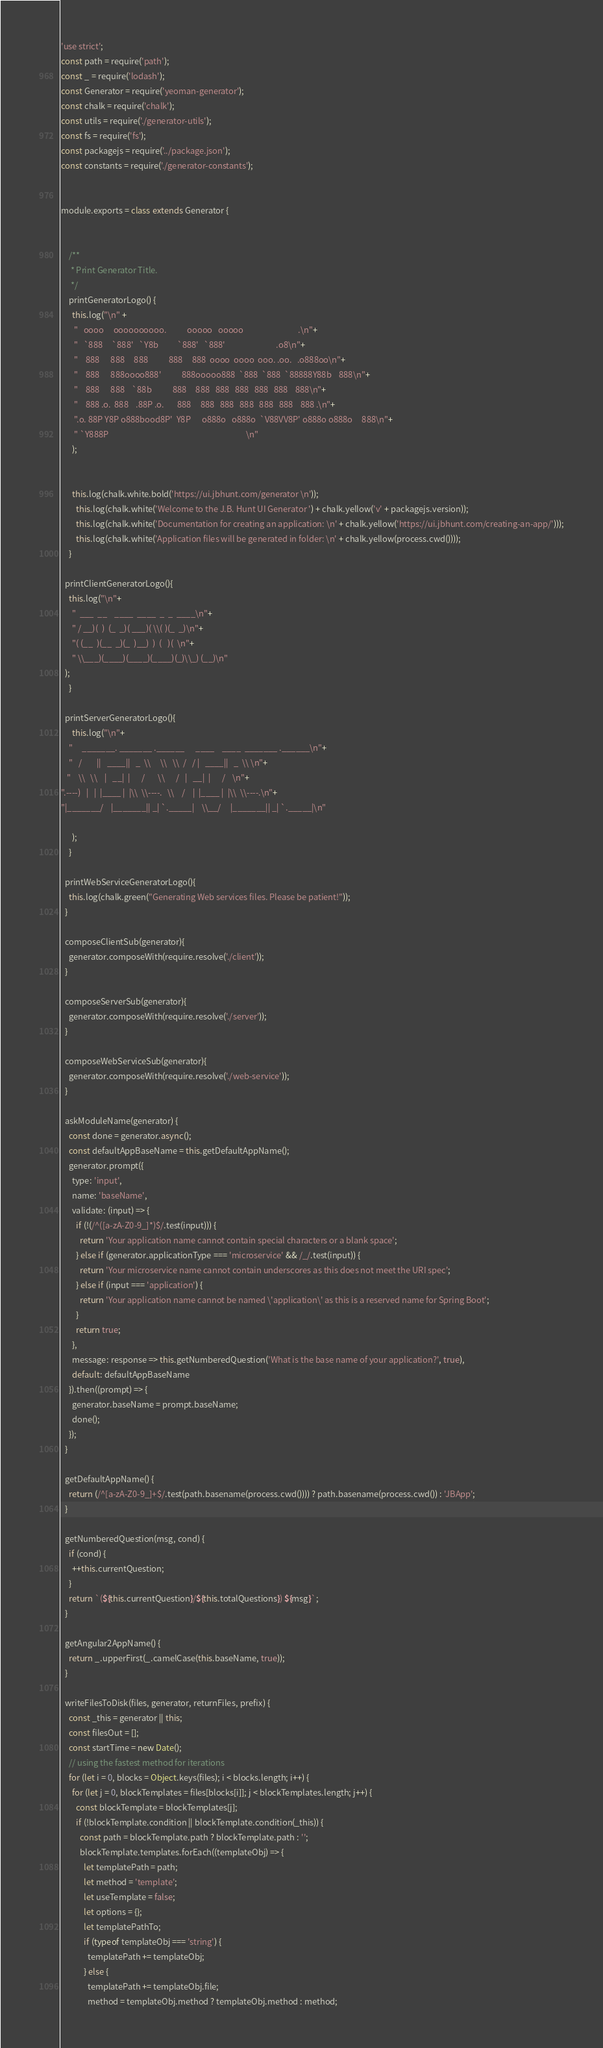<code> <loc_0><loc_0><loc_500><loc_500><_JavaScript_>'use strict';
const path = require('path');
const _ = require('lodash');
const Generator = require('yeoman-generator');
const chalk = require('chalk');
const utils = require('./generator-utils');
const fs = require('fs');
const packagejs = require('../package.json');
const constants = require('./generator-constants');


module.exports = class extends Generator {


    /**
     * Print Generator Title.
     */
    printGeneratorLogo() {
      this.log("\n" +
       "   oooo     oooooooooo.           ooooo   ooooo                             .\n"+
       "   `888     `888'   `Y8b          `888'   `888'                           .o8\n"+
       "    888      888     888           888     888  oooo  oooo  ooo. .oo.   .o888oo\n"+
       "    888      888oooo888'           888ooooo888  `888  `888  `88888Y88b    888\n"+
       "    888      888    `88b           888     888   888   888   888   888    888\n"+
       "    888 .o.  888    .88P .o.       888     888   888   888   888   888    888 .\n"+
       ".o. 88P Y8P o888bood8P'  Y8P      o888o   o888o  `V88VV8P' o888o o888o     888\n"+
       " `Y888P                                                                         \n"
      );


      this.log(chalk.white.bold('https://ui.jbhunt.com/generator \n'));
        this.log(chalk.white('Welcome to the J.B. Hunt UI Generator ') + chalk.yellow('v' + packagejs.version));
        this.log(chalk.white('Documentation for creating an application: \n' + chalk.yellow('https://ui.jbhunt.com/creating-an-app/')));
        this.log(chalk.white('Application files will be generated in folder: \n' + chalk.yellow(process.cwd())));
    }

  printClientGeneratorLogo(){
    this.log("\n"+
      "  ___  __    ____  ____  _  _  ____\n"+
      " / __)(  )  (_  _)( ___)( \\( )(_  _)\n"+
      "( (__  )(__  _)(_  )__)  )  (   )(  \n"+
      " \\___)(____)(____)(____)(_)\\_) (__)\n"
  );
    }

  printServerGeneratorLogo(){
      this.log("\n"+
    "     _______. _______ .______      ____    ____  _______ .______\n"+
    "   /        ||   ____||   _  \\     \\   \\  /   / |   ____||   _  \\ \n"+
   "    \\   \\    |   __|  |      /       \\      /   |   __|  |      /    \n"+
".----)   |   |  |____ |  |\\  \\----.   \\    /    |  |____ |  |\\  \\----.\n"+
"|_______/    |_______|| _| `._____|    \\__/     |_______|| _| `._____|\n"

      );
    }

  printWebServiceGeneratorLogo(){
    this.log(chalk.green("Generating Web services files. Please be patient!"));
  }

  composeClientSub(generator){
    generator.composeWith(require.resolve('./client'));
  }

  composeServerSub(generator){
    generator.composeWith(require.resolve('./server'));
  }

  composeWebServiceSub(generator){
    generator.composeWith(require.resolve('./web-service'));
  }

  askModuleName(generator) {
    const done = generator.async();
    const defaultAppBaseName = this.getDefaultAppName();
    generator.prompt({
      type: 'input',
      name: 'baseName',
      validate: (input) => {
        if (!(/^([a-zA-Z0-9_]*)$/.test(input))) {
          return 'Your application name cannot contain special characters or a blank space';
        } else if (generator.applicationType === 'microservice' && /_/.test(input)) {
          return 'Your microservice name cannot contain underscores as this does not meet the URI spec';
        } else if (input === 'application') {
          return 'Your application name cannot be named \'application\' as this is a reserved name for Spring Boot';
        }
        return true;
      },
      message: response => this.getNumberedQuestion('What is the base name of your application?', true),
      default: defaultAppBaseName
    }).then((prompt) => {
      generator.baseName = prompt.baseName;
      done();
    });
  }

  getDefaultAppName() {
    return (/^[a-zA-Z0-9_]+$/.test(path.basename(process.cwd()))) ? path.basename(process.cwd()) : 'JBApp';
  }

  getNumberedQuestion(msg, cond) {
    if (cond) {
      ++this.currentQuestion;
    }
    return `(${this.currentQuestion}/${this.totalQuestions}) ${msg}`;
  }

  getAngular2AppName() {
    return _.upperFirst(_.camelCase(this.baseName, true));
  }

  writeFilesToDisk(files, generator, returnFiles, prefix) {
    const _this = generator || this;
    const filesOut = [];
    const startTime = new Date();
    // using the fastest method for iterations
    for (let i = 0, blocks = Object.keys(files); i < blocks.length; i++) {
      for (let j = 0, blockTemplates = files[blocks[i]]; j < blockTemplates.length; j++) {
        const blockTemplate = blockTemplates[j];
        if (!blockTemplate.condition || blockTemplate.condition(_this)) {
          const path = blockTemplate.path ? blockTemplate.path : '';
          blockTemplate.templates.forEach((templateObj) => {
            let templatePath = path;
            let method = 'template';
            let useTemplate = false;
            let options = {};
            let templatePathTo;
            if (typeof templateObj === 'string') {
              templatePath += templateObj;
            } else {
              templatePath += templateObj.file;
              method = templateObj.method ? templateObj.method : method;</code> 